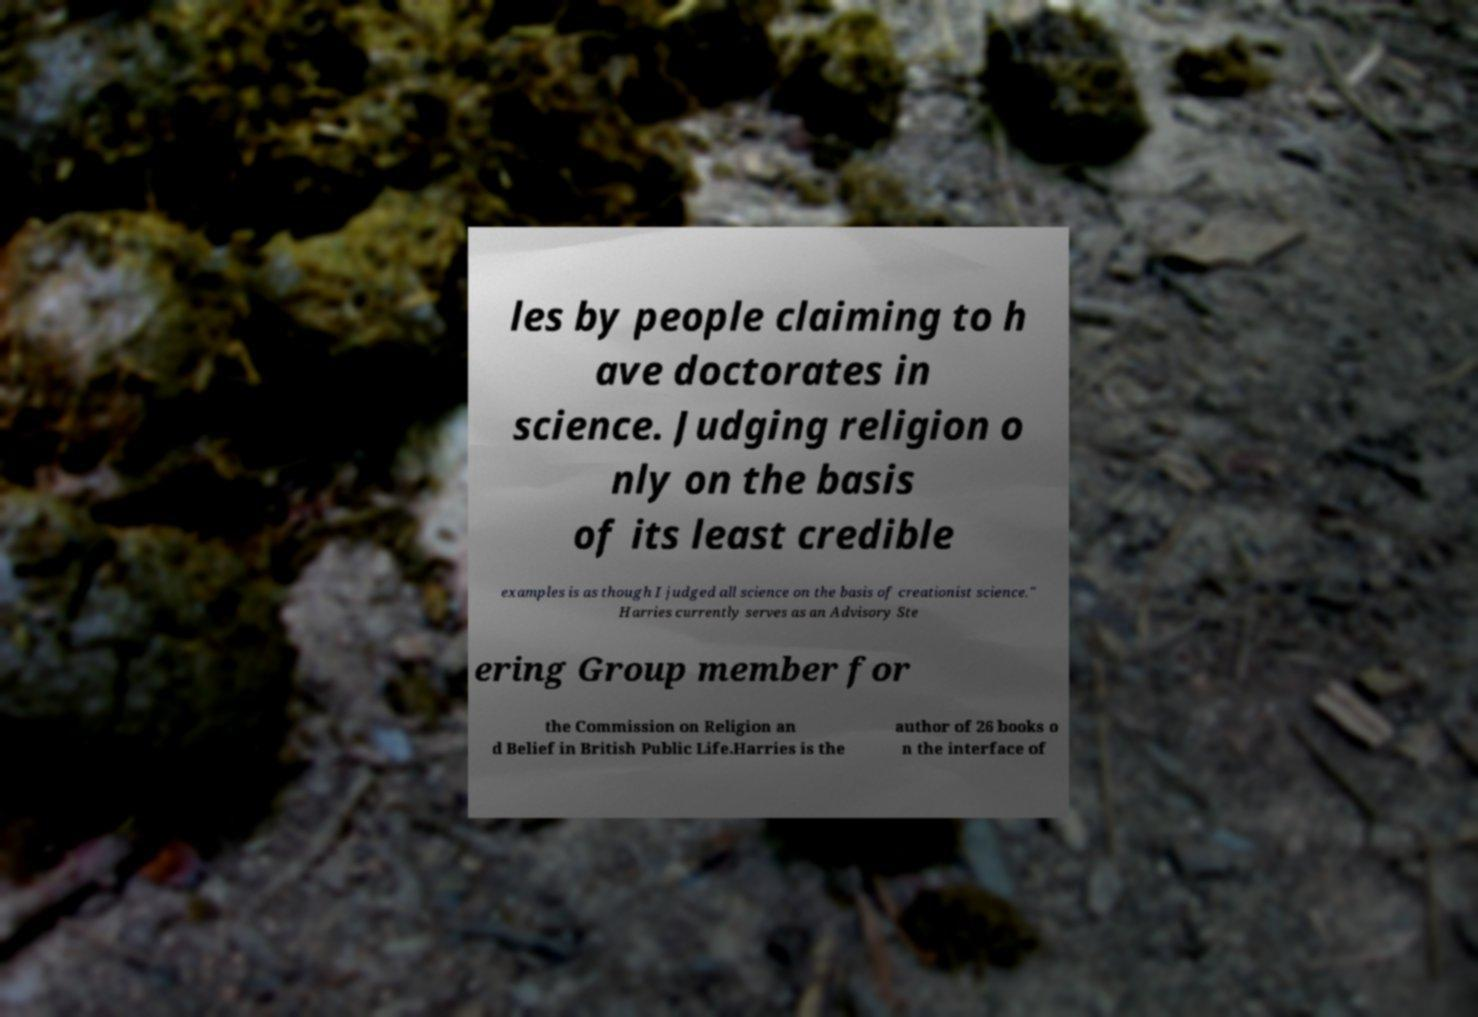Please identify and transcribe the text found in this image. les by people claiming to h ave doctorates in science. Judging religion o nly on the basis of its least credible examples is as though I judged all science on the basis of creationist science." Harries currently serves as an Advisory Ste ering Group member for the Commission on Religion an d Belief in British Public Life.Harries is the author of 26 books o n the interface of 